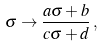<formula> <loc_0><loc_0><loc_500><loc_500>\sigma \to \frac { a \sigma + b } { c \sigma + d } \, ,</formula> 